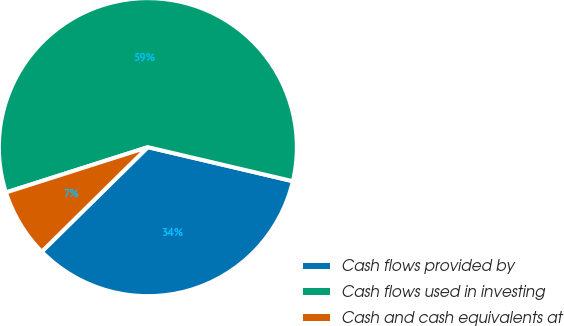Convert chart. <chart><loc_0><loc_0><loc_500><loc_500><pie_chart><fcel>Cash flows provided by<fcel>Cash flows used in investing<fcel>Cash and cash equivalents at<nl><fcel>33.95%<fcel>58.59%<fcel>7.46%<nl></chart> 